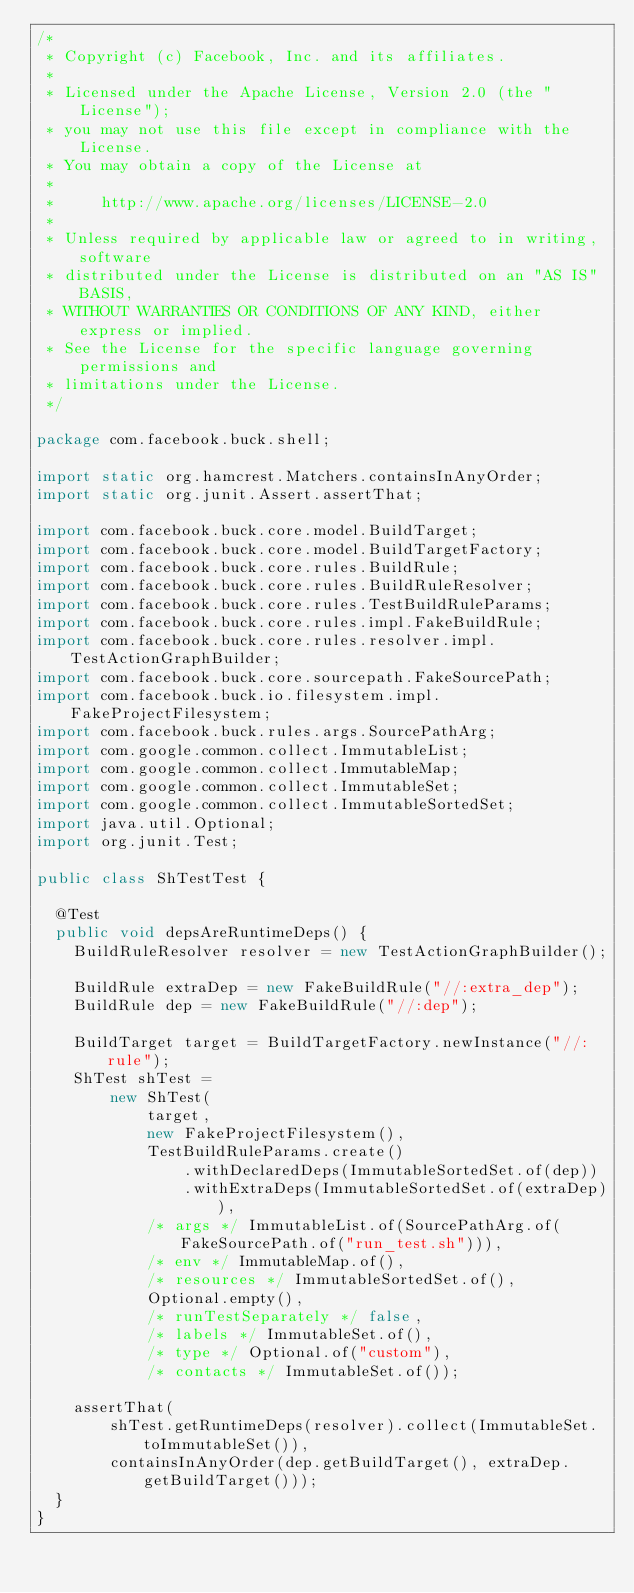<code> <loc_0><loc_0><loc_500><loc_500><_Java_>/*
 * Copyright (c) Facebook, Inc. and its affiliates.
 *
 * Licensed under the Apache License, Version 2.0 (the "License");
 * you may not use this file except in compliance with the License.
 * You may obtain a copy of the License at
 *
 *     http://www.apache.org/licenses/LICENSE-2.0
 *
 * Unless required by applicable law or agreed to in writing, software
 * distributed under the License is distributed on an "AS IS" BASIS,
 * WITHOUT WARRANTIES OR CONDITIONS OF ANY KIND, either express or implied.
 * See the License for the specific language governing permissions and
 * limitations under the License.
 */

package com.facebook.buck.shell;

import static org.hamcrest.Matchers.containsInAnyOrder;
import static org.junit.Assert.assertThat;

import com.facebook.buck.core.model.BuildTarget;
import com.facebook.buck.core.model.BuildTargetFactory;
import com.facebook.buck.core.rules.BuildRule;
import com.facebook.buck.core.rules.BuildRuleResolver;
import com.facebook.buck.core.rules.TestBuildRuleParams;
import com.facebook.buck.core.rules.impl.FakeBuildRule;
import com.facebook.buck.core.rules.resolver.impl.TestActionGraphBuilder;
import com.facebook.buck.core.sourcepath.FakeSourcePath;
import com.facebook.buck.io.filesystem.impl.FakeProjectFilesystem;
import com.facebook.buck.rules.args.SourcePathArg;
import com.google.common.collect.ImmutableList;
import com.google.common.collect.ImmutableMap;
import com.google.common.collect.ImmutableSet;
import com.google.common.collect.ImmutableSortedSet;
import java.util.Optional;
import org.junit.Test;

public class ShTestTest {

  @Test
  public void depsAreRuntimeDeps() {
    BuildRuleResolver resolver = new TestActionGraphBuilder();

    BuildRule extraDep = new FakeBuildRule("//:extra_dep");
    BuildRule dep = new FakeBuildRule("//:dep");

    BuildTarget target = BuildTargetFactory.newInstance("//:rule");
    ShTest shTest =
        new ShTest(
            target,
            new FakeProjectFilesystem(),
            TestBuildRuleParams.create()
                .withDeclaredDeps(ImmutableSortedSet.of(dep))
                .withExtraDeps(ImmutableSortedSet.of(extraDep)),
            /* args */ ImmutableList.of(SourcePathArg.of(FakeSourcePath.of("run_test.sh"))),
            /* env */ ImmutableMap.of(),
            /* resources */ ImmutableSortedSet.of(),
            Optional.empty(),
            /* runTestSeparately */ false,
            /* labels */ ImmutableSet.of(),
            /* type */ Optional.of("custom"),
            /* contacts */ ImmutableSet.of());

    assertThat(
        shTest.getRuntimeDeps(resolver).collect(ImmutableSet.toImmutableSet()),
        containsInAnyOrder(dep.getBuildTarget(), extraDep.getBuildTarget()));
  }
}
</code> 